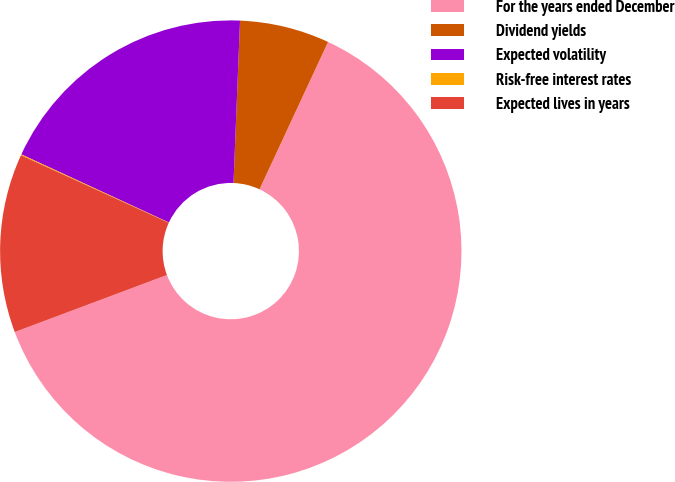Convert chart. <chart><loc_0><loc_0><loc_500><loc_500><pie_chart><fcel>For the years ended December<fcel>Dividend yields<fcel>Expected volatility<fcel>Risk-free interest rates<fcel>Expected lives in years<nl><fcel>62.36%<fcel>6.29%<fcel>18.75%<fcel>0.07%<fcel>12.52%<nl></chart> 